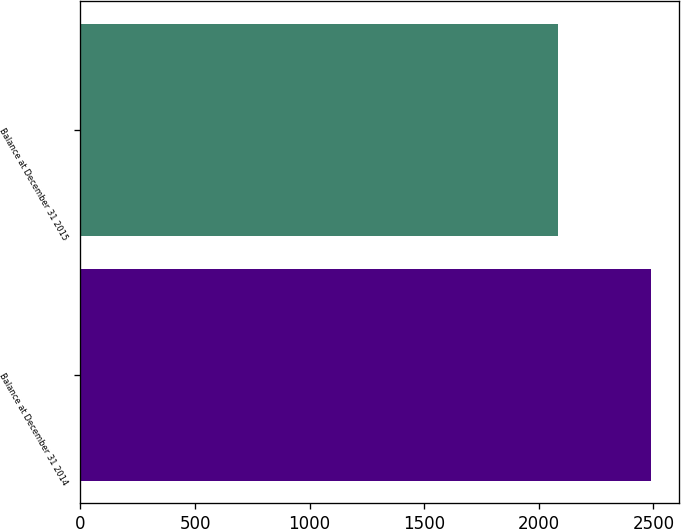<chart> <loc_0><loc_0><loc_500><loc_500><bar_chart><fcel>Balance at December 31 2014<fcel>Balance at December 31 2015<nl><fcel>2488<fcel>2085<nl></chart> 